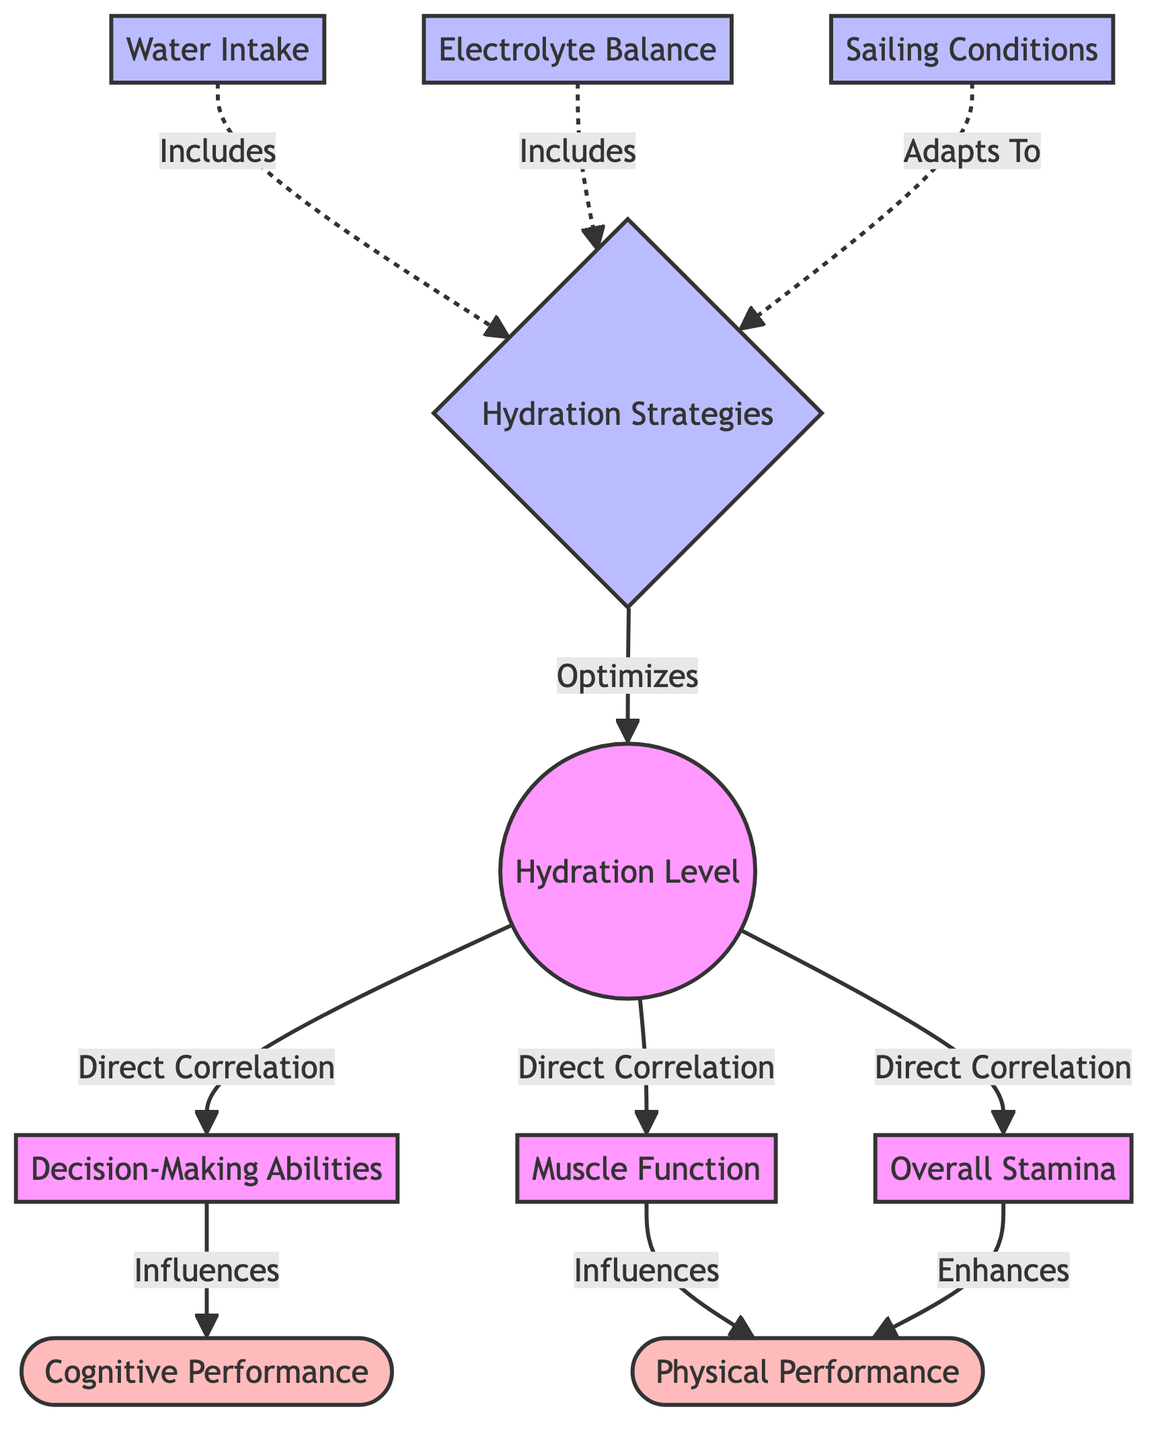What is directly correlated with hydration level? The diagram shows that hydration level is directly correlated with decision-making abilities, muscle function, and overall stamina. Thus, the specific node being referred to is decision-making abilities.
Answer: Decision-Making Abilities How many hydration strategies are mentioned in the diagram? The diagram includes three hydration strategies: water intake, electrolyte balance, and adaptation to sailing conditions. Counting these gives us a total of three.
Answer: Three What influences cognitive performance according to the diagram? The diagram illustrates that cognitive performance is influenced by decision-making abilities, which results from hydration levels. Therefore, the direct influence is through the decision-making abilities.
Answer: Decision-Making Abilities What enhances physical performance? According to the diagram, overall stamina directly enhances physical performance, as indicated by the flow relationship between these two nodes.
Answer: Overall Stamina Which factors include hydration strategies? The diagram highlights that water intake and electrolyte balance are factors that include hydration strategies, as both are depicted with dotted lines leading to hydration strategies.
Answer: Water Intake and Electrolyte Balance 